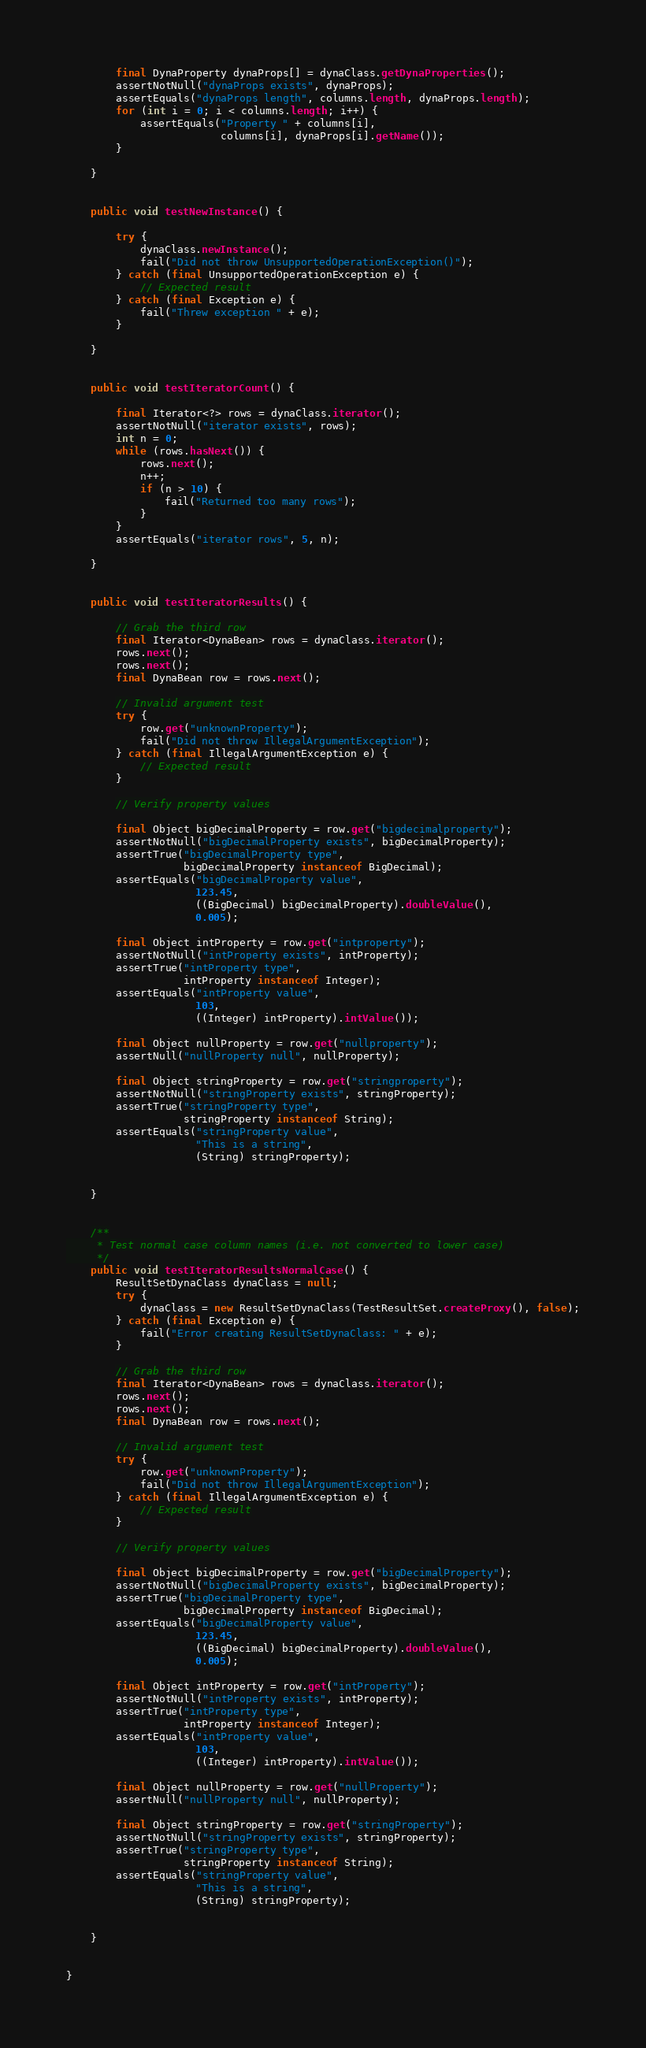<code> <loc_0><loc_0><loc_500><loc_500><_Java_>
        final DynaProperty dynaProps[] = dynaClass.getDynaProperties();
        assertNotNull("dynaProps exists", dynaProps);
        assertEquals("dynaProps length", columns.length, dynaProps.length);
        for (int i = 0; i < columns.length; i++) {
            assertEquals("Property " + columns[i],
                         columns[i], dynaProps[i].getName());
        }

    }


    public void testNewInstance() {

        try {
            dynaClass.newInstance();
            fail("Did not throw UnsupportedOperationException()");
        } catch (final UnsupportedOperationException e) {
            // Expected result
        } catch (final Exception e) {
            fail("Threw exception " + e);
        }

    }


    public void testIteratorCount() {

        final Iterator<?> rows = dynaClass.iterator();
        assertNotNull("iterator exists", rows);
        int n = 0;
        while (rows.hasNext()) {
            rows.next();
            n++;
            if (n > 10) {
                fail("Returned too many rows");
            }
        }
        assertEquals("iterator rows", 5, n);

    }


    public void testIteratorResults() {

        // Grab the third row
        final Iterator<DynaBean> rows = dynaClass.iterator();
        rows.next();
        rows.next();
        final DynaBean row = rows.next();

        // Invalid argument test
        try {
            row.get("unknownProperty");
            fail("Did not throw IllegalArgumentException");
        } catch (final IllegalArgumentException e) {
            // Expected result
        }

        // Verify property values

        final Object bigDecimalProperty = row.get("bigdecimalproperty");
        assertNotNull("bigDecimalProperty exists", bigDecimalProperty);
        assertTrue("bigDecimalProperty type",
                   bigDecimalProperty instanceof BigDecimal);
        assertEquals("bigDecimalProperty value",
                     123.45,
                     ((BigDecimal) bigDecimalProperty).doubleValue(),
                     0.005);

        final Object intProperty = row.get("intproperty");
        assertNotNull("intProperty exists", intProperty);
        assertTrue("intProperty type",
                   intProperty instanceof Integer);
        assertEquals("intProperty value",
                     103,
                     ((Integer) intProperty).intValue());

        final Object nullProperty = row.get("nullproperty");
        assertNull("nullProperty null", nullProperty);

        final Object stringProperty = row.get("stringproperty");
        assertNotNull("stringProperty exists", stringProperty);
        assertTrue("stringProperty type",
                   stringProperty instanceof String);
        assertEquals("stringProperty value",
                     "This is a string",
                     (String) stringProperty);


    }


    /**
     * Test normal case column names (i.e. not converted to lower case)
     */
    public void testIteratorResultsNormalCase() {
        ResultSetDynaClass dynaClass = null;
        try {
            dynaClass = new ResultSetDynaClass(TestResultSet.createProxy(), false);
        } catch (final Exception e) {
            fail("Error creating ResultSetDynaClass: " + e);
        }

        // Grab the third row
        final Iterator<DynaBean> rows = dynaClass.iterator();
        rows.next();
        rows.next();
        final DynaBean row = rows.next();

        // Invalid argument test
        try {
            row.get("unknownProperty");
            fail("Did not throw IllegalArgumentException");
        } catch (final IllegalArgumentException e) {
            // Expected result
        }

        // Verify property values

        final Object bigDecimalProperty = row.get("bigDecimalProperty");
        assertNotNull("bigDecimalProperty exists", bigDecimalProperty);
        assertTrue("bigDecimalProperty type",
                   bigDecimalProperty instanceof BigDecimal);
        assertEquals("bigDecimalProperty value",
                     123.45,
                     ((BigDecimal) bigDecimalProperty).doubleValue(),
                     0.005);

        final Object intProperty = row.get("intProperty");
        assertNotNull("intProperty exists", intProperty);
        assertTrue("intProperty type",
                   intProperty instanceof Integer);
        assertEquals("intProperty value",
                     103,
                     ((Integer) intProperty).intValue());

        final Object nullProperty = row.get("nullProperty");
        assertNull("nullProperty null", nullProperty);

        final Object stringProperty = row.get("stringProperty");
        assertNotNull("stringProperty exists", stringProperty);
        assertTrue("stringProperty type",
                   stringProperty instanceof String);
        assertEquals("stringProperty value",
                     "This is a string",
                     (String) stringProperty);


    }


}
</code> 